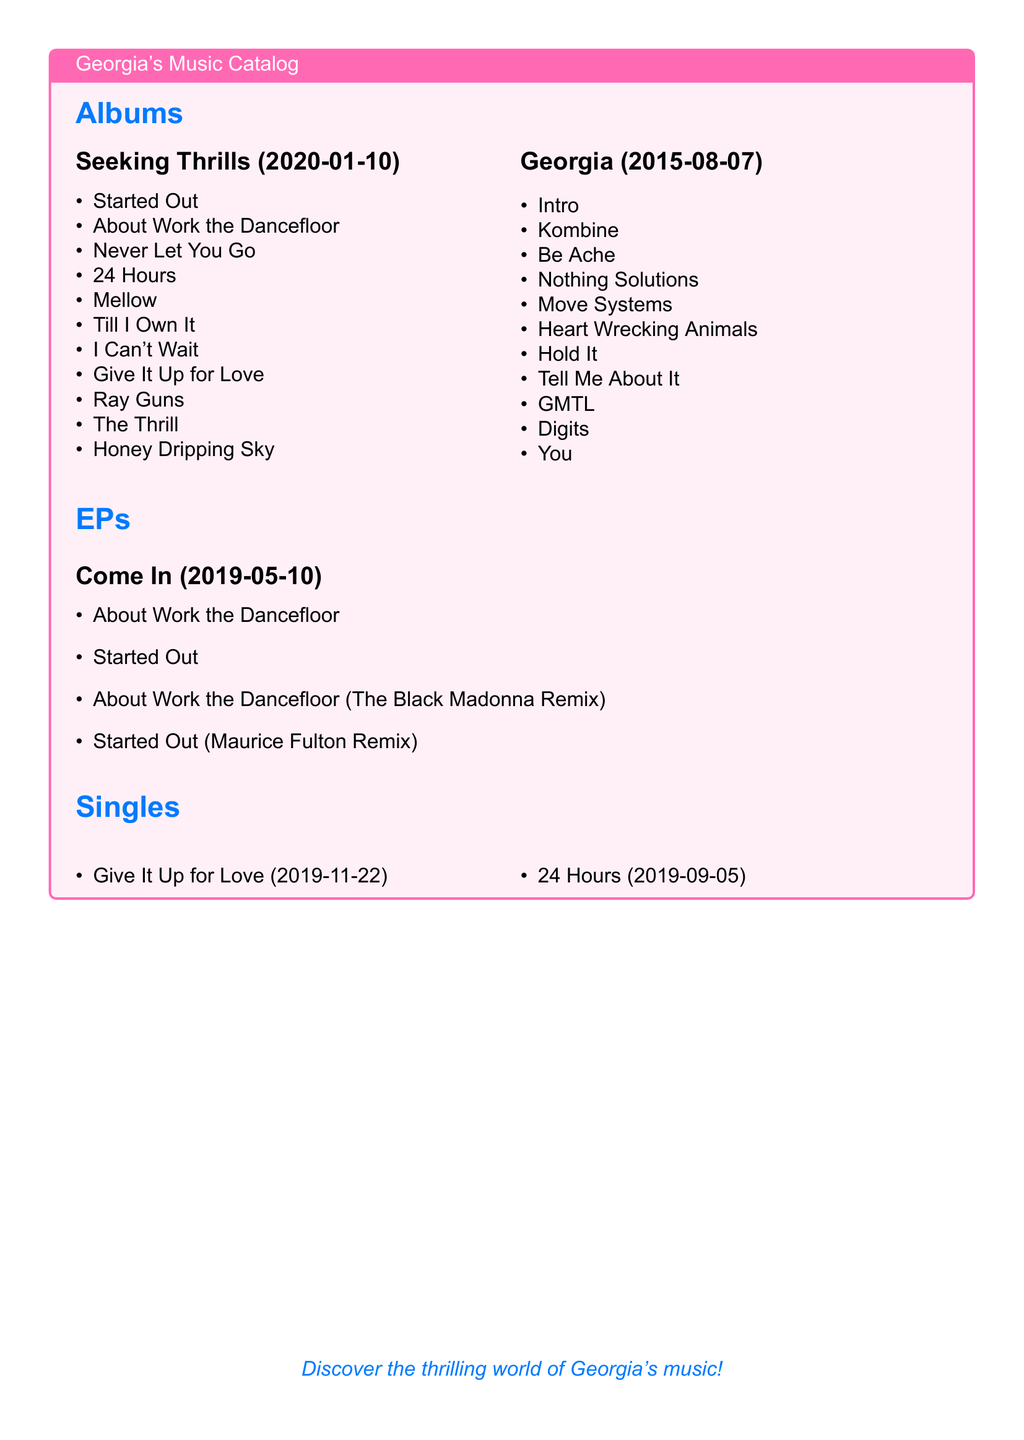What is the release date of the album "Seeking Thrills"? The release date can be found in the document under the album title "Seeking Thrills", which states 2020-01-10.
Answer: 2020-01-10 How many tracks are in the album "Georgia"? The number of tracks can be counted from the track listing provided for the album "Georgia", which lists 11 tracks.
Answer: 11 Who is the artist of the single "Give It Up for Love"? The single information is under the "Singles" section, which lists "Give It Up for Love" and indicates it is by Georgia.
Answer: Georgia What is the title of the third track from "Seeking Thrills"? The track listings for "Seeking Thrills" reveal that the third track is "Never Let You Go".
Answer: Never Let You Go What is the total number of albums listed in this catalog? By counting the sections labeled "Albums," there are two albums listed in the catalog: "Seeking Thrills" and "Georgia."
Answer: 2 When was the EP "Come In" released? The release date is provided directly next to the EP title "Come In", which is listed as 2019-05-10.
Answer: 2019-05-10 Which single was released on September 5, 2019? The single release dates show that "24 Hours" is listed with the date 2019-09-05.
Answer: 24 Hours What color is used in the title formatting? The color used in the title formatting is stated as "georgiablue" in the document's formatting section.
Answer: georgiablue What is the title of Georgia's debut album? The document includes the album list and the first album listed is "Georgia", as indicated in the albums section.
Answer: Georgia 